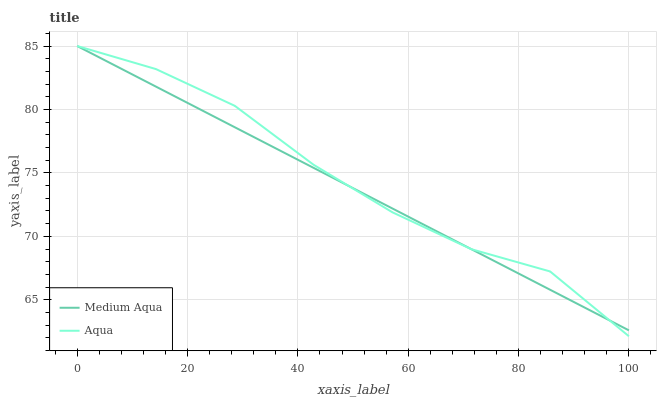Does Medium Aqua have the minimum area under the curve?
Answer yes or no. Yes. Does Aqua have the maximum area under the curve?
Answer yes or no. Yes. Does Medium Aqua have the maximum area under the curve?
Answer yes or no. No. Is Medium Aqua the smoothest?
Answer yes or no. Yes. Is Aqua the roughest?
Answer yes or no. Yes. Is Medium Aqua the roughest?
Answer yes or no. No. Does Aqua have the lowest value?
Answer yes or no. Yes. Does Medium Aqua have the lowest value?
Answer yes or no. No. Does Medium Aqua have the highest value?
Answer yes or no. Yes. Does Medium Aqua intersect Aqua?
Answer yes or no. Yes. Is Medium Aqua less than Aqua?
Answer yes or no. No. Is Medium Aqua greater than Aqua?
Answer yes or no. No. 